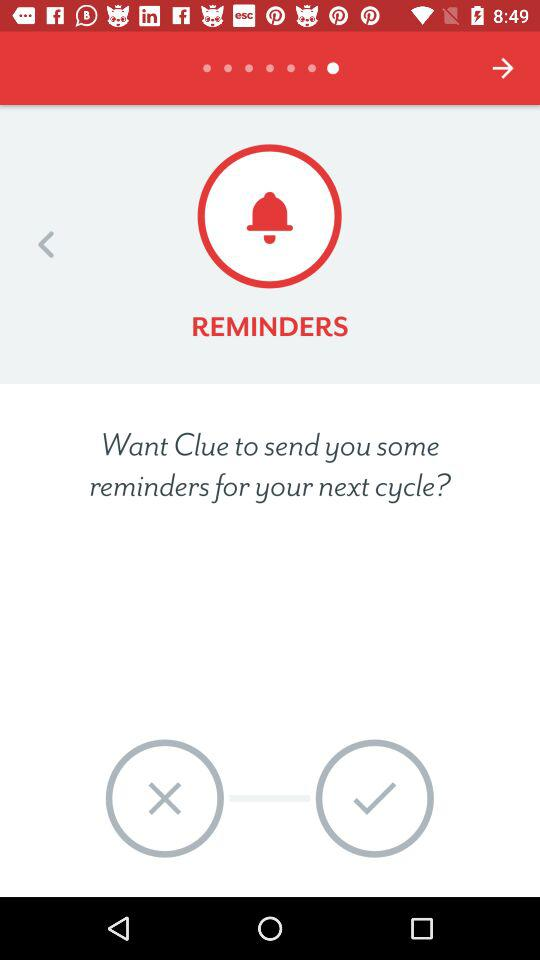How many more arrows are there than check marks?
Answer the question using a single word or phrase. 1 